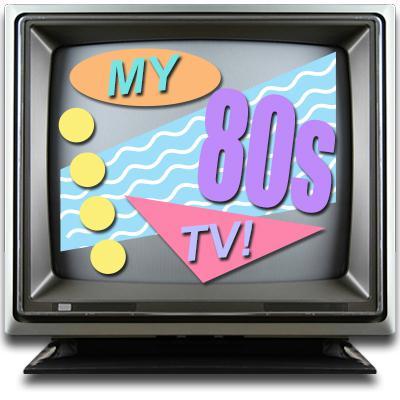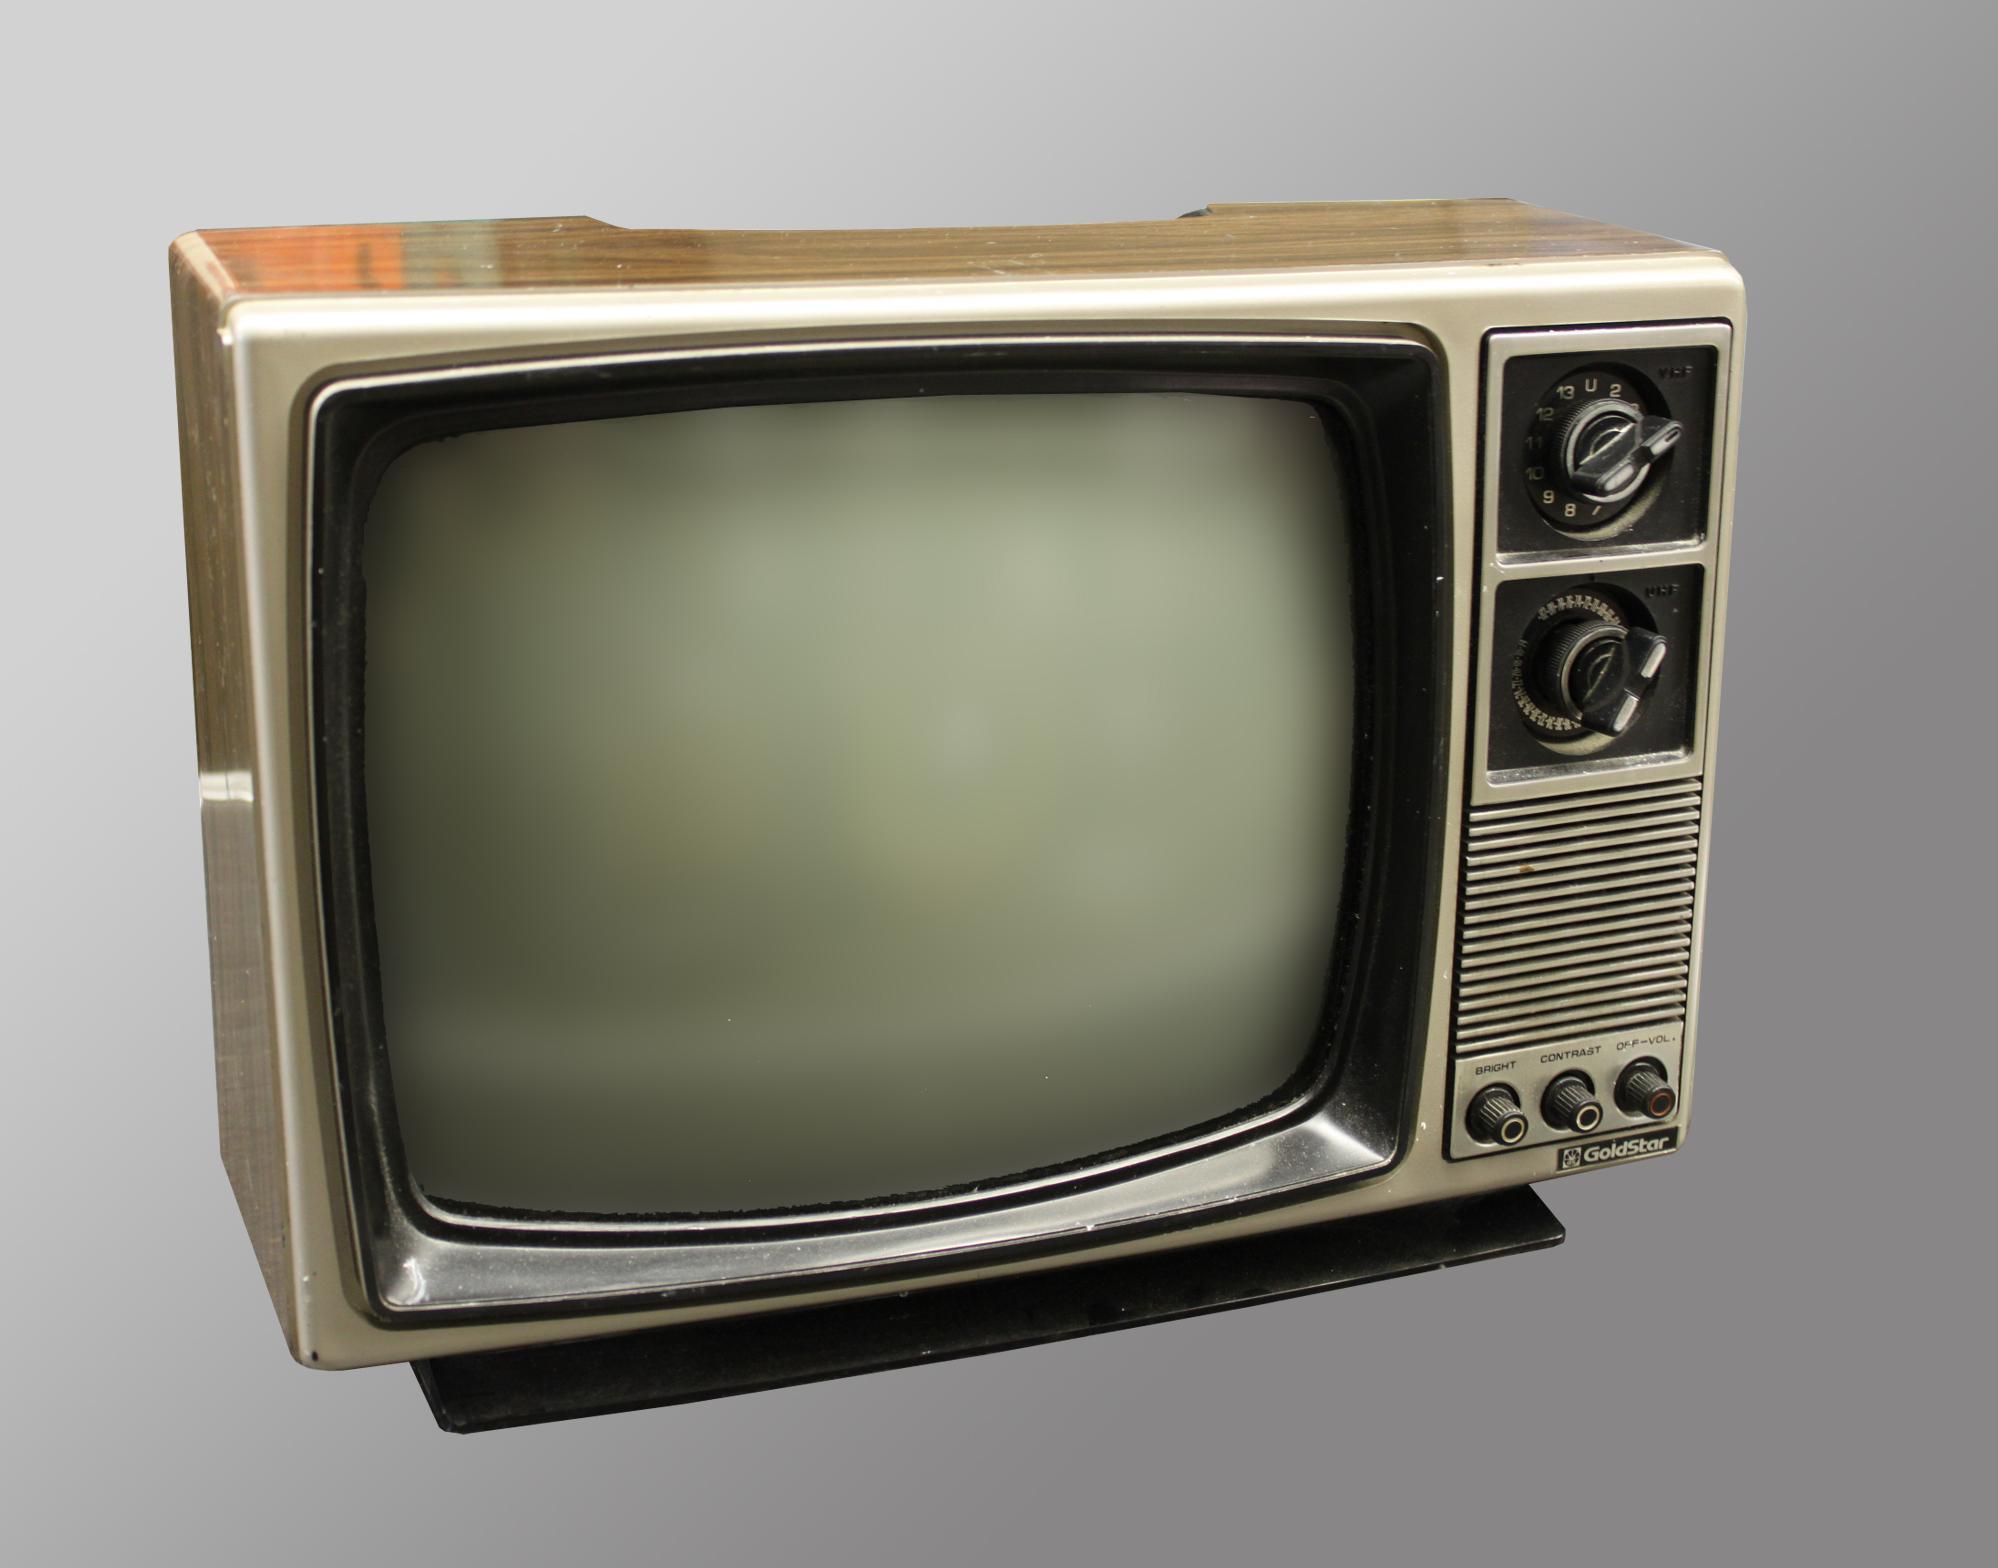The first image is the image on the left, the second image is the image on the right. Examine the images to the left and right. Is the description "One TV has three small knobs in a horizontal row at the bottom right and two black rectangles arranged one over the other on the upper right." accurate? Answer yes or no. Yes. The first image is the image on the left, the second image is the image on the right. Given the left and right images, does the statement "One TV is sitting outside with grass and trees in the background." hold true? Answer yes or no. No. 